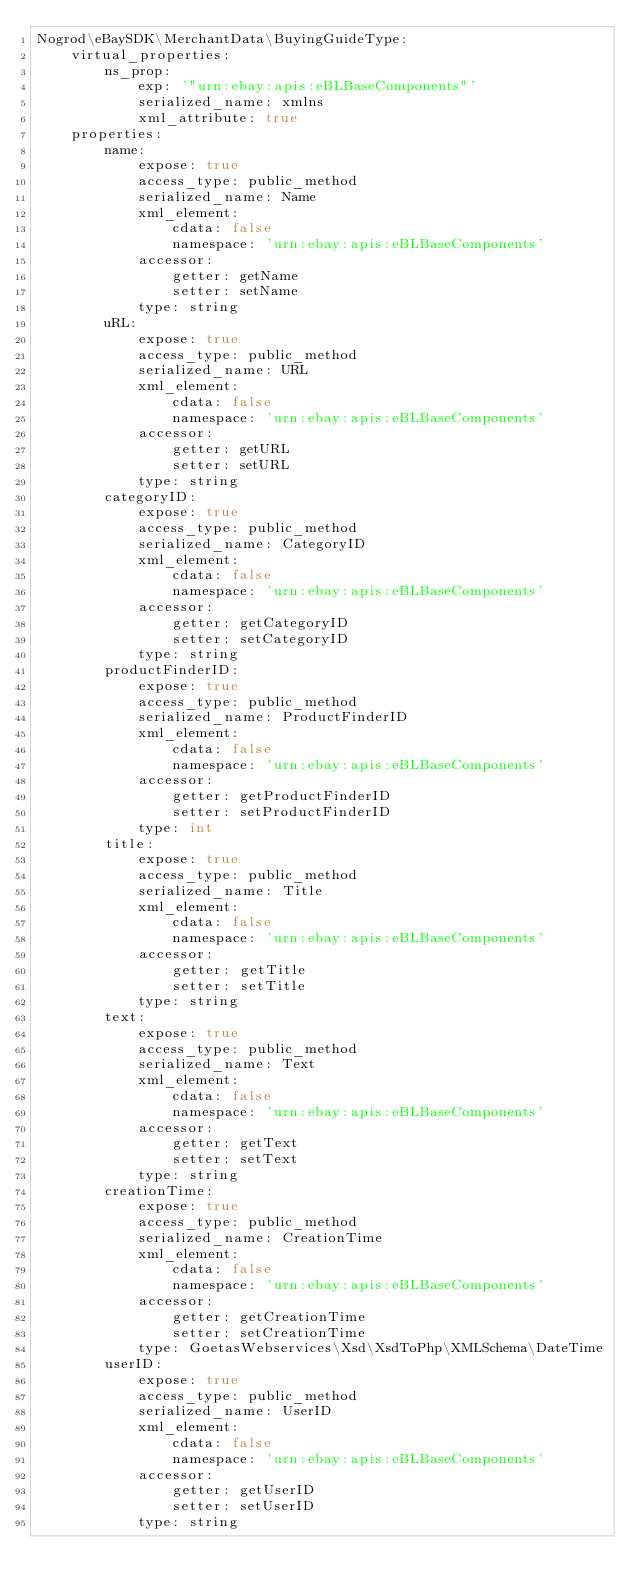<code> <loc_0><loc_0><loc_500><loc_500><_YAML_>Nogrod\eBaySDK\MerchantData\BuyingGuideType:
    virtual_properties:
        ns_prop:
            exp: '"urn:ebay:apis:eBLBaseComponents"'
            serialized_name: xmlns
            xml_attribute: true
    properties:
        name:
            expose: true
            access_type: public_method
            serialized_name: Name
            xml_element:
                cdata: false
                namespace: 'urn:ebay:apis:eBLBaseComponents'
            accessor:
                getter: getName
                setter: setName
            type: string
        uRL:
            expose: true
            access_type: public_method
            serialized_name: URL
            xml_element:
                cdata: false
                namespace: 'urn:ebay:apis:eBLBaseComponents'
            accessor:
                getter: getURL
                setter: setURL
            type: string
        categoryID:
            expose: true
            access_type: public_method
            serialized_name: CategoryID
            xml_element:
                cdata: false
                namespace: 'urn:ebay:apis:eBLBaseComponents'
            accessor:
                getter: getCategoryID
                setter: setCategoryID
            type: string
        productFinderID:
            expose: true
            access_type: public_method
            serialized_name: ProductFinderID
            xml_element:
                cdata: false
                namespace: 'urn:ebay:apis:eBLBaseComponents'
            accessor:
                getter: getProductFinderID
                setter: setProductFinderID
            type: int
        title:
            expose: true
            access_type: public_method
            serialized_name: Title
            xml_element:
                cdata: false
                namespace: 'urn:ebay:apis:eBLBaseComponents'
            accessor:
                getter: getTitle
                setter: setTitle
            type: string
        text:
            expose: true
            access_type: public_method
            serialized_name: Text
            xml_element:
                cdata: false
                namespace: 'urn:ebay:apis:eBLBaseComponents'
            accessor:
                getter: getText
                setter: setText
            type: string
        creationTime:
            expose: true
            access_type: public_method
            serialized_name: CreationTime
            xml_element:
                cdata: false
                namespace: 'urn:ebay:apis:eBLBaseComponents'
            accessor:
                getter: getCreationTime
                setter: setCreationTime
            type: GoetasWebservices\Xsd\XsdToPhp\XMLSchema\DateTime
        userID:
            expose: true
            access_type: public_method
            serialized_name: UserID
            xml_element:
                cdata: false
                namespace: 'urn:ebay:apis:eBLBaseComponents'
            accessor:
                getter: getUserID
                setter: setUserID
            type: string
</code> 